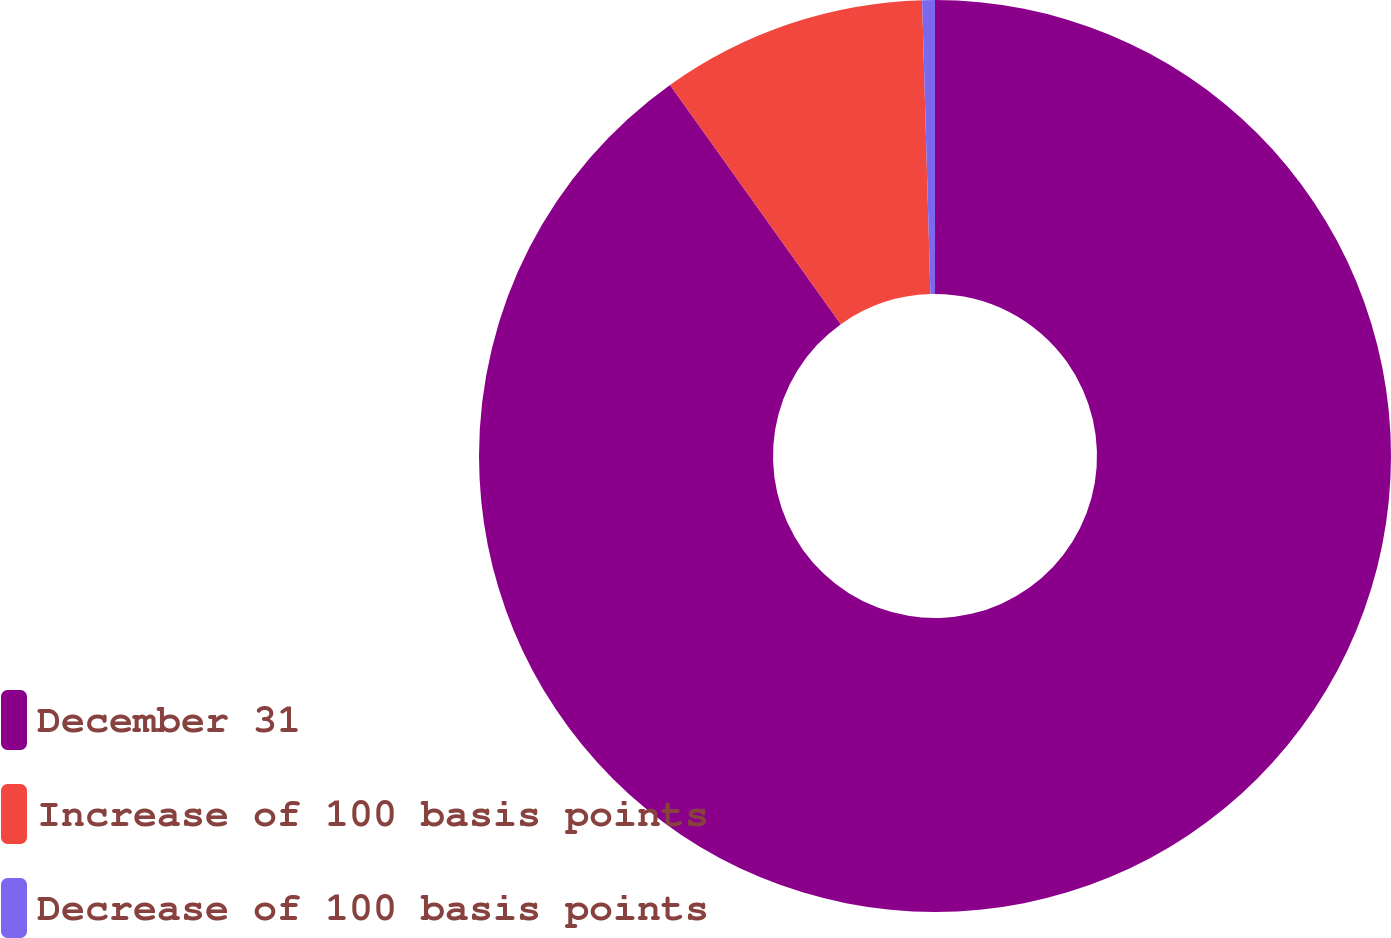Convert chart. <chart><loc_0><loc_0><loc_500><loc_500><pie_chart><fcel>December 31<fcel>Increase of 100 basis points<fcel>Decrease of 100 basis points<nl><fcel>90.14%<fcel>9.42%<fcel>0.45%<nl></chart> 